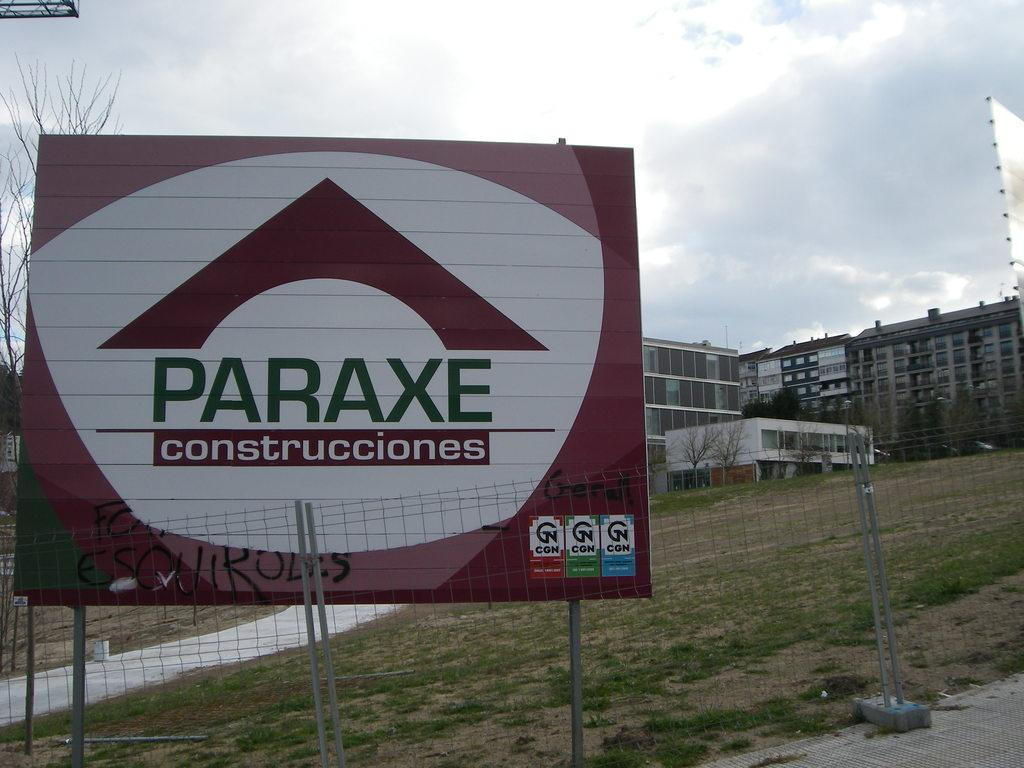<image>
Relay a brief, clear account of the picture shown. A billboard showing that the building is for the Paraxe Construcciones company. 